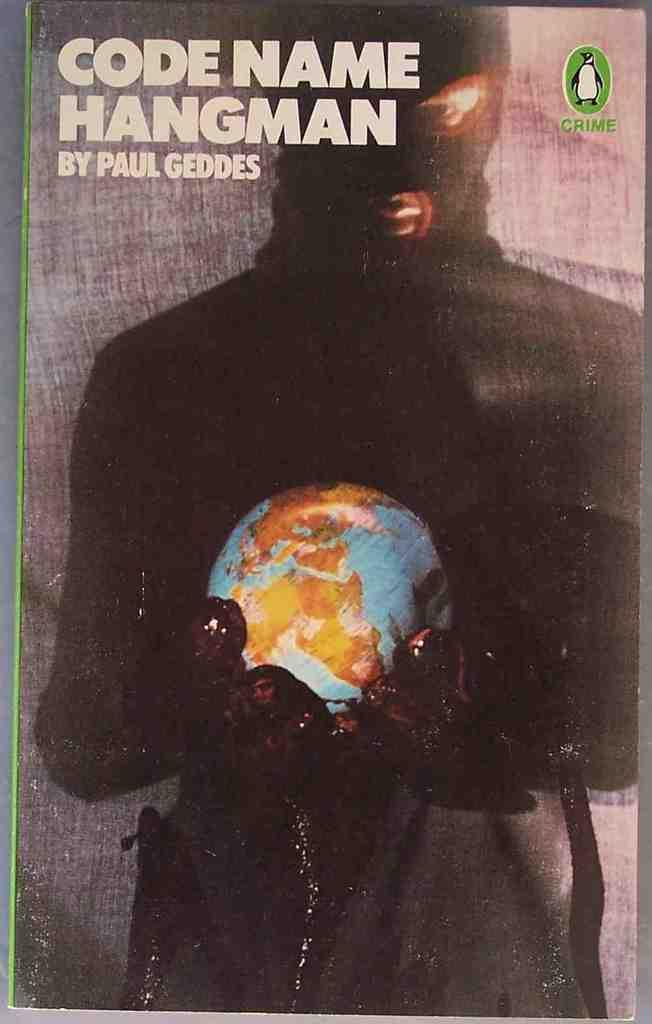What is the main subject of the poster in the image? The poster features a man holding a globe. Where is the text located on the poster? The text is in the top left corner of the poster. What other element can be seen in the top right corner of the poster? There is a penguin in the top right corner of the poster. What type of chalk is the man using to draw on the penguin in the image? There is no chalk or drawing activity present in the image; the man is holding a globe, and there is a penguin in the top right corner of the poster. 